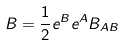Convert formula to latex. <formula><loc_0><loc_0><loc_500><loc_500>B = \frac { 1 } { 2 } e ^ { B } e ^ { A } B _ { A B }</formula> 